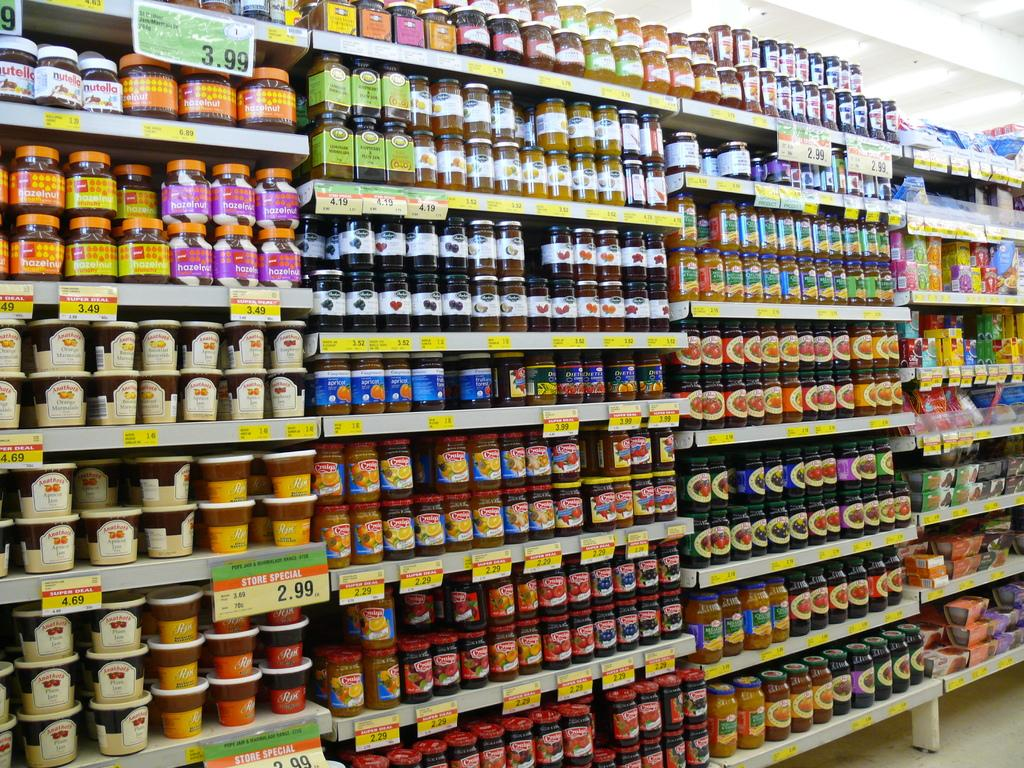What type of objects are in the image? There are containers and boxes in the image. How are the containers and boxes arranged? The containers and boxes are in a rack. What other objects can be seen in the image? There are boards in the image. What is visible at the top of the image? There are lights at the top of the image. Can you tell me how many aunts are holding the sand in the image? There is no sand or aunt present in the image. 